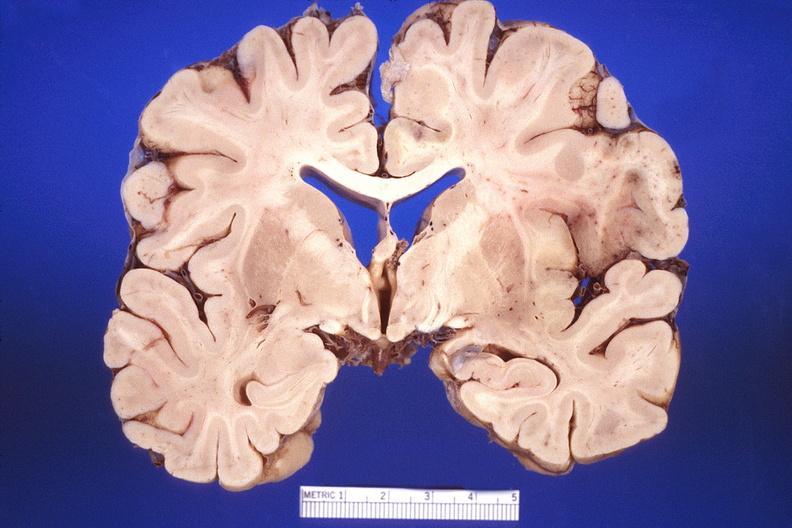s surface present?
Answer the question using a single word or phrase. No 